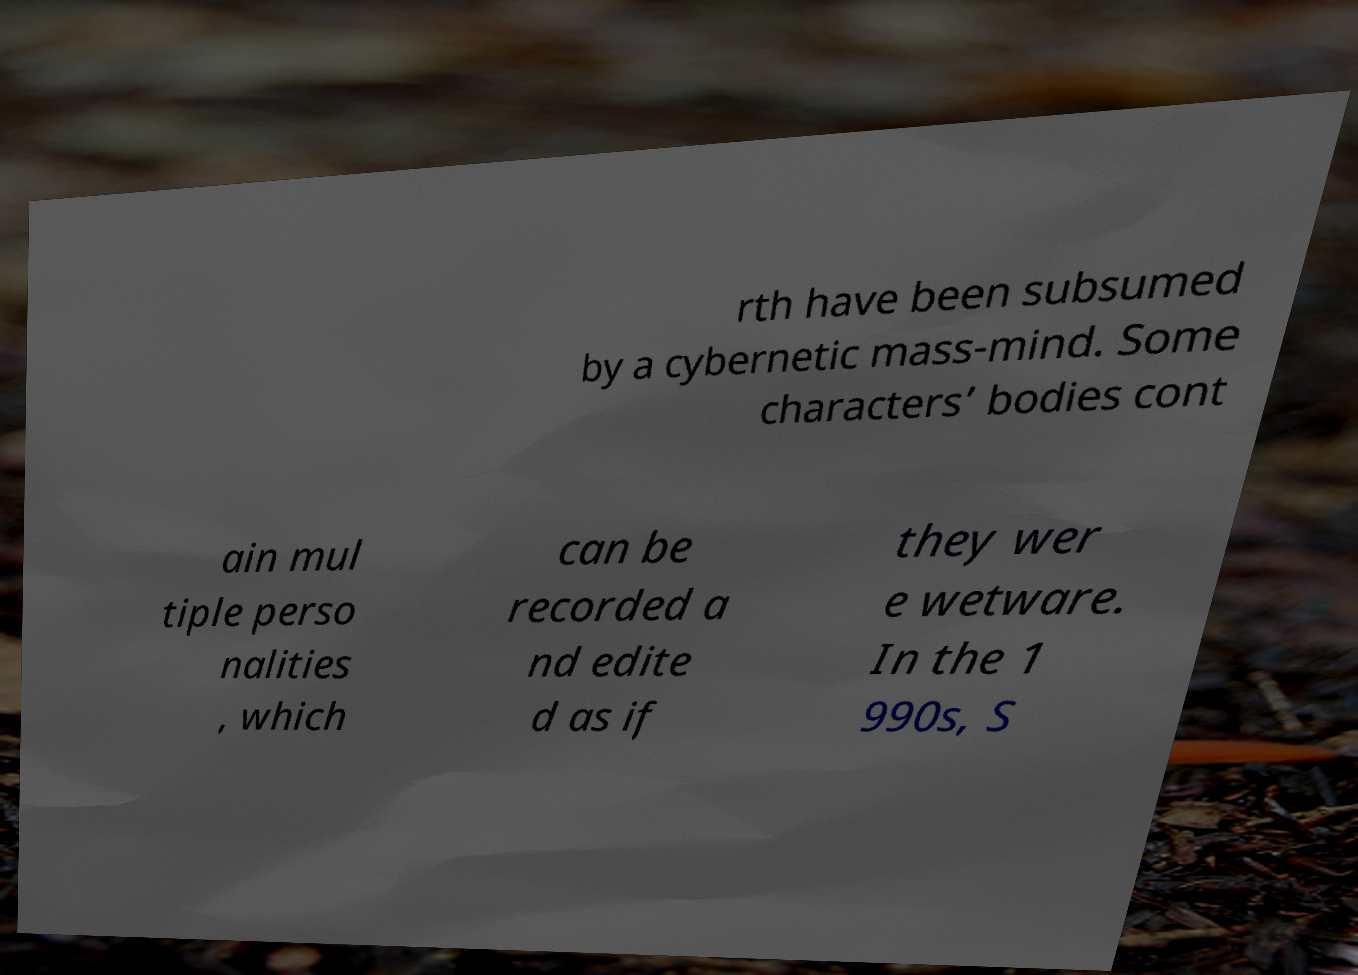Please read and relay the text visible in this image. What does it say? rth have been subsumed by a cybernetic mass-mind. Some characters’ bodies cont ain mul tiple perso nalities , which can be recorded a nd edite d as if they wer e wetware. In the 1 990s, S 